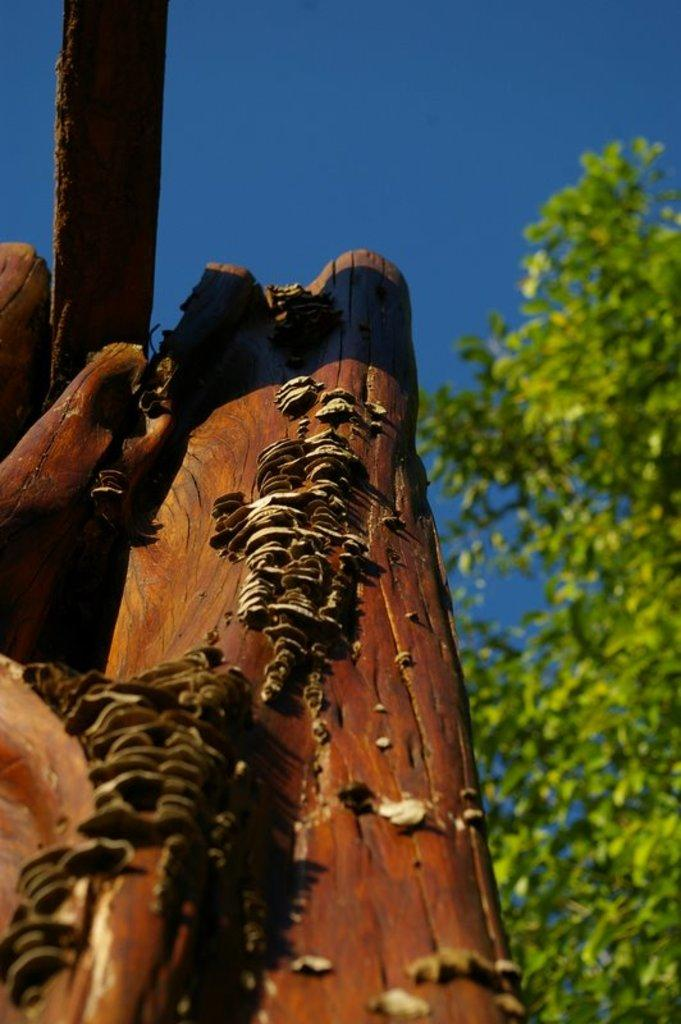What material is present in the image? There is wood in the image. What type of natural objects can be seen in the image? There are trees in the image. What is visible in the background of the image? The sky is visible in the background of the image. How many nails can be seen holding the wood together in the image? There are no nails visible in the image; it only shows wood and trees. What type of animal can be seen interacting with the wood in the image? There is no animal present in the image; it only wood and trees are visible. 